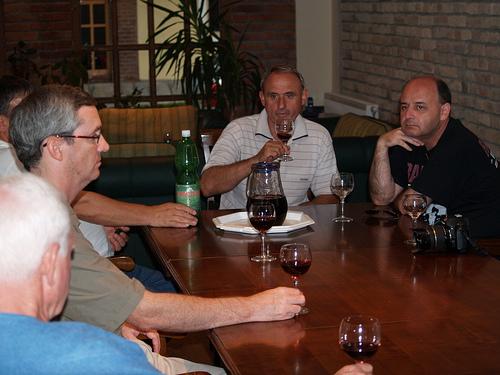Are any women visible in this picture?
Concise answer only. No. How many people are drinking?
Answer briefly. 5. What drink is different than all the rest?
Quick response, please. Soda. 